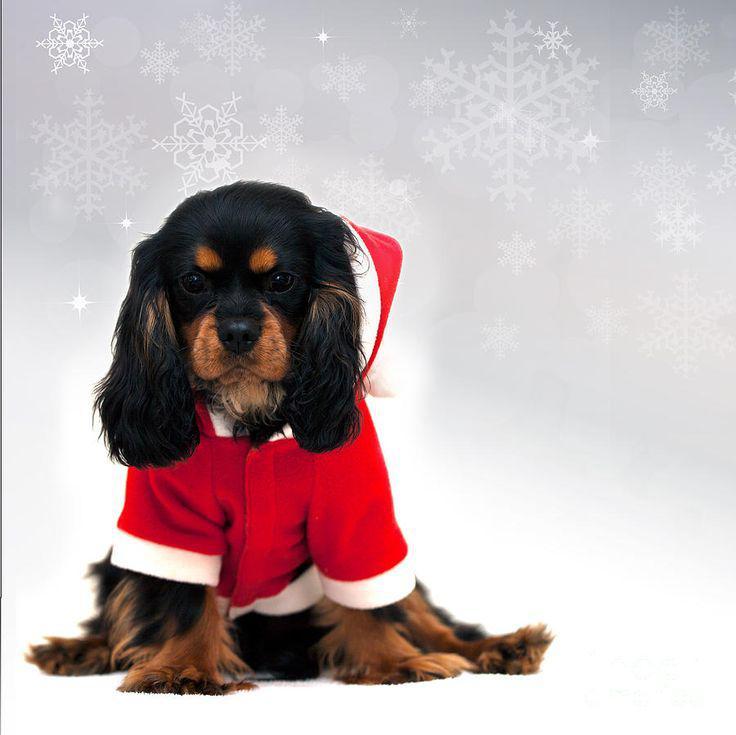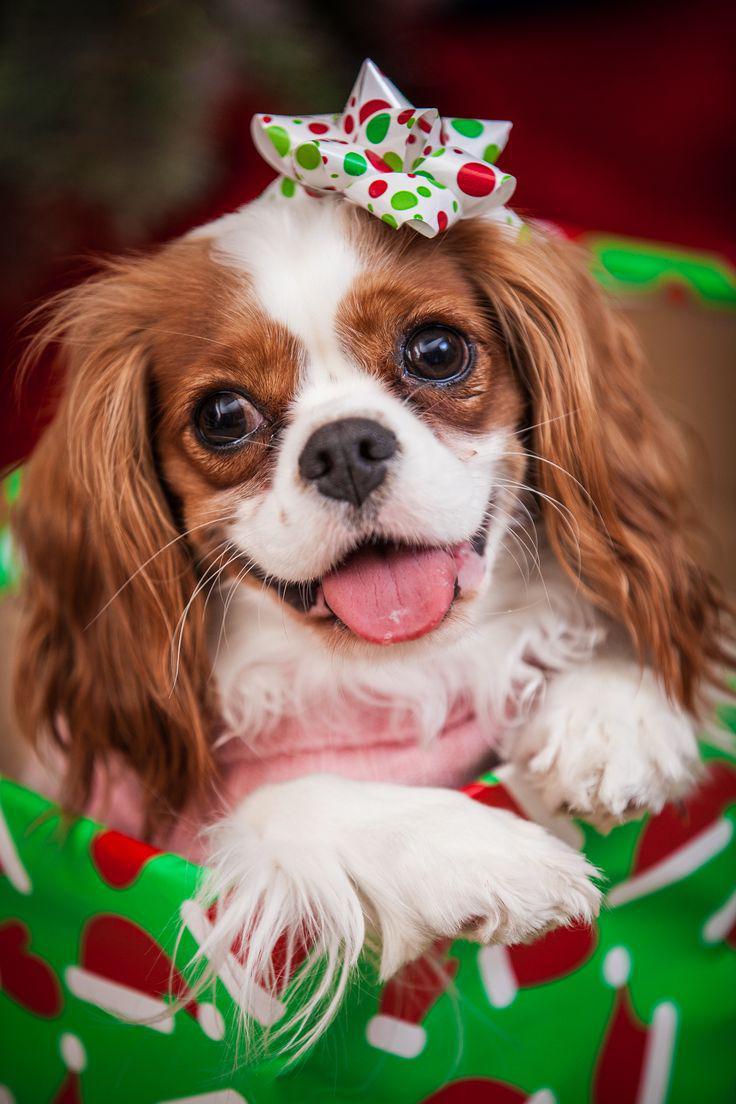The first image is the image on the left, the second image is the image on the right. Evaluate the accuracy of this statement regarding the images: "An image shows one puppy in a Santa hat and another puppy behind the hat.". Is it true? Answer yes or no. No. The first image is the image on the left, the second image is the image on the right. Evaluate the accuracy of this statement regarding the images: "The left image shows a black, white and brown dog inside a santa hat and a brown and white dog next to it". Is it true? Answer yes or no. No. 